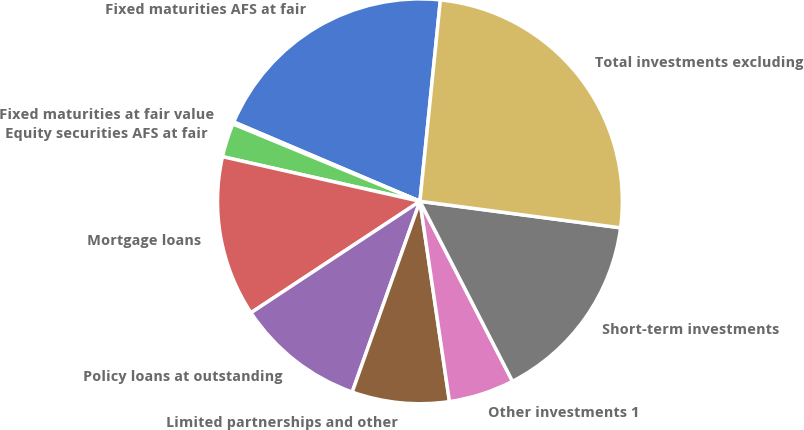Convert chart. <chart><loc_0><loc_0><loc_500><loc_500><pie_chart><fcel>Fixed maturities AFS at fair<fcel>Fixed maturities at fair value<fcel>Equity securities AFS at fair<fcel>Mortgage loans<fcel>Policy loans at outstanding<fcel>Limited partnerships and other<fcel>Other investments 1<fcel>Short-term investments<fcel>Total investments excluding<nl><fcel>20.2%<fcel>0.17%<fcel>2.7%<fcel>12.82%<fcel>10.29%<fcel>7.76%<fcel>5.23%<fcel>15.35%<fcel>25.48%<nl></chart> 